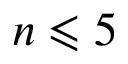Convert formula to latex. <formula><loc_0><loc_0><loc_500><loc_500>n \leqslant 5</formula> 